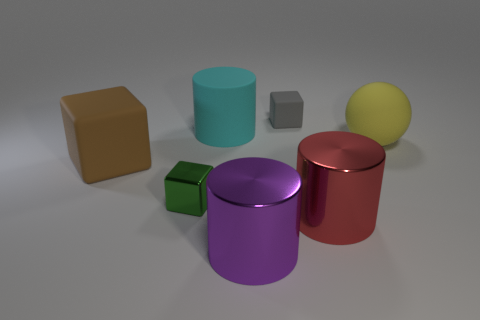There is another small metallic object that is the same shape as the gray thing; what is its color?
Your answer should be compact. Green. Are there any other things that are the same shape as the cyan object?
Offer a terse response. Yes. There is a tiny object behind the green metallic object; is its color the same as the tiny shiny thing?
Provide a succinct answer. No. The brown rubber object that is the same shape as the green metallic object is what size?
Offer a very short reply. Large. What number of big spheres have the same material as the large red thing?
Your answer should be very brief. 0. Are there any cubes on the right side of the matte ball behind the matte object that is to the left of the tiny green metallic object?
Make the answer very short. No. What shape is the big red thing?
Offer a very short reply. Cylinder. Are the thing in front of the big red object and the tiny block on the left side of the large purple shiny cylinder made of the same material?
Provide a succinct answer. Yes. How many rubber cylinders have the same color as the large block?
Provide a succinct answer. 0. What shape is the object that is both behind the ball and in front of the tiny gray matte block?
Offer a terse response. Cylinder. 